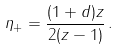<formula> <loc_0><loc_0><loc_500><loc_500>\eta _ { + } = \frac { ( 1 + d ) z } { 2 ( z - 1 ) } \, .</formula> 